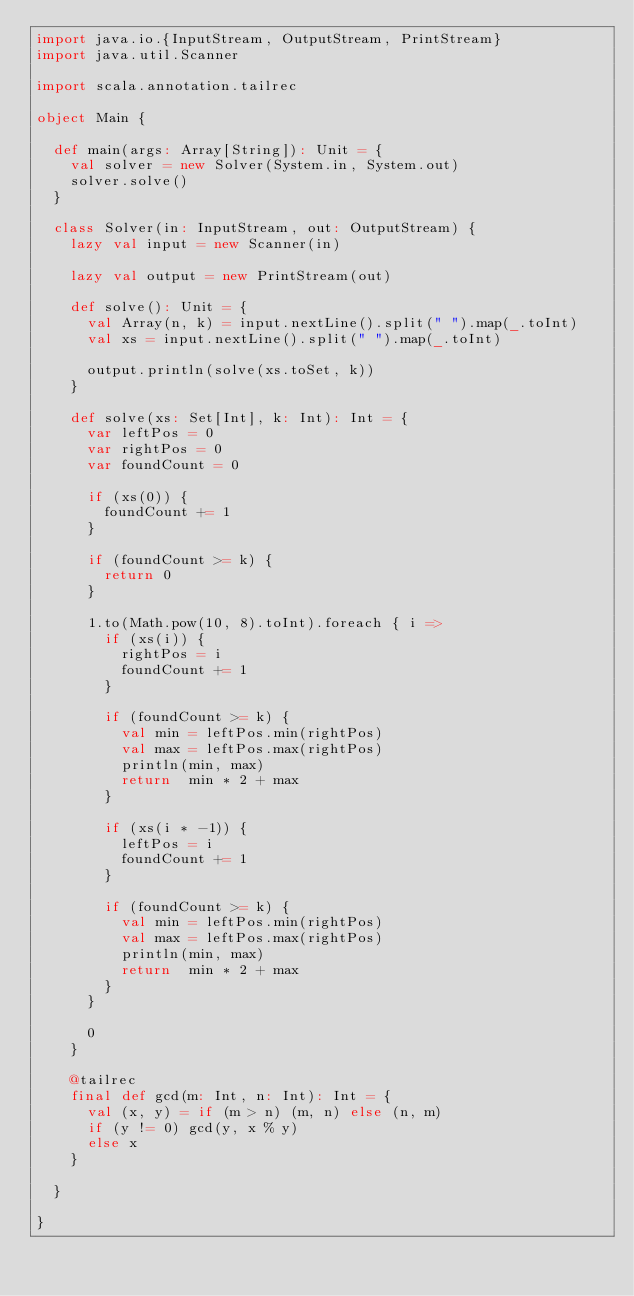<code> <loc_0><loc_0><loc_500><loc_500><_Scala_>import java.io.{InputStream, OutputStream, PrintStream}
import java.util.Scanner

import scala.annotation.tailrec

object Main {

  def main(args: Array[String]): Unit = {
    val solver = new Solver(System.in, System.out)
    solver.solve()
  }

  class Solver(in: InputStream, out: OutputStream) {
    lazy val input = new Scanner(in)

    lazy val output = new PrintStream(out)

    def solve(): Unit = {
      val Array(n, k) = input.nextLine().split(" ").map(_.toInt)
      val xs = input.nextLine().split(" ").map(_.toInt)

      output.println(solve(xs.toSet, k))
    }

    def solve(xs: Set[Int], k: Int): Int = {
      var leftPos = 0
      var rightPos = 0
      var foundCount = 0

      if (xs(0)) {
        foundCount += 1
      }

      if (foundCount >= k) {
        return 0
      }

      1.to(Math.pow(10, 8).toInt).foreach { i =>
        if (xs(i)) {
          rightPos = i
          foundCount += 1
        }

        if (foundCount >= k) {
          val min = leftPos.min(rightPos)
          val max = leftPos.max(rightPos)
          println(min, max)
          return  min * 2 + max
        }

        if (xs(i * -1)) {
          leftPos = i
          foundCount += 1
        }

        if (foundCount >= k) {
          val min = leftPos.min(rightPos)
          val max = leftPos.max(rightPos)
          println(min, max)
          return  min * 2 + max
        }
      }

      0
    }

    @tailrec
    final def gcd(m: Int, n: Int): Int = {
      val (x, y) = if (m > n) (m, n) else (n, m)
      if (y != 0) gcd(y, x % y)
      else x
    }

  }

}
</code> 